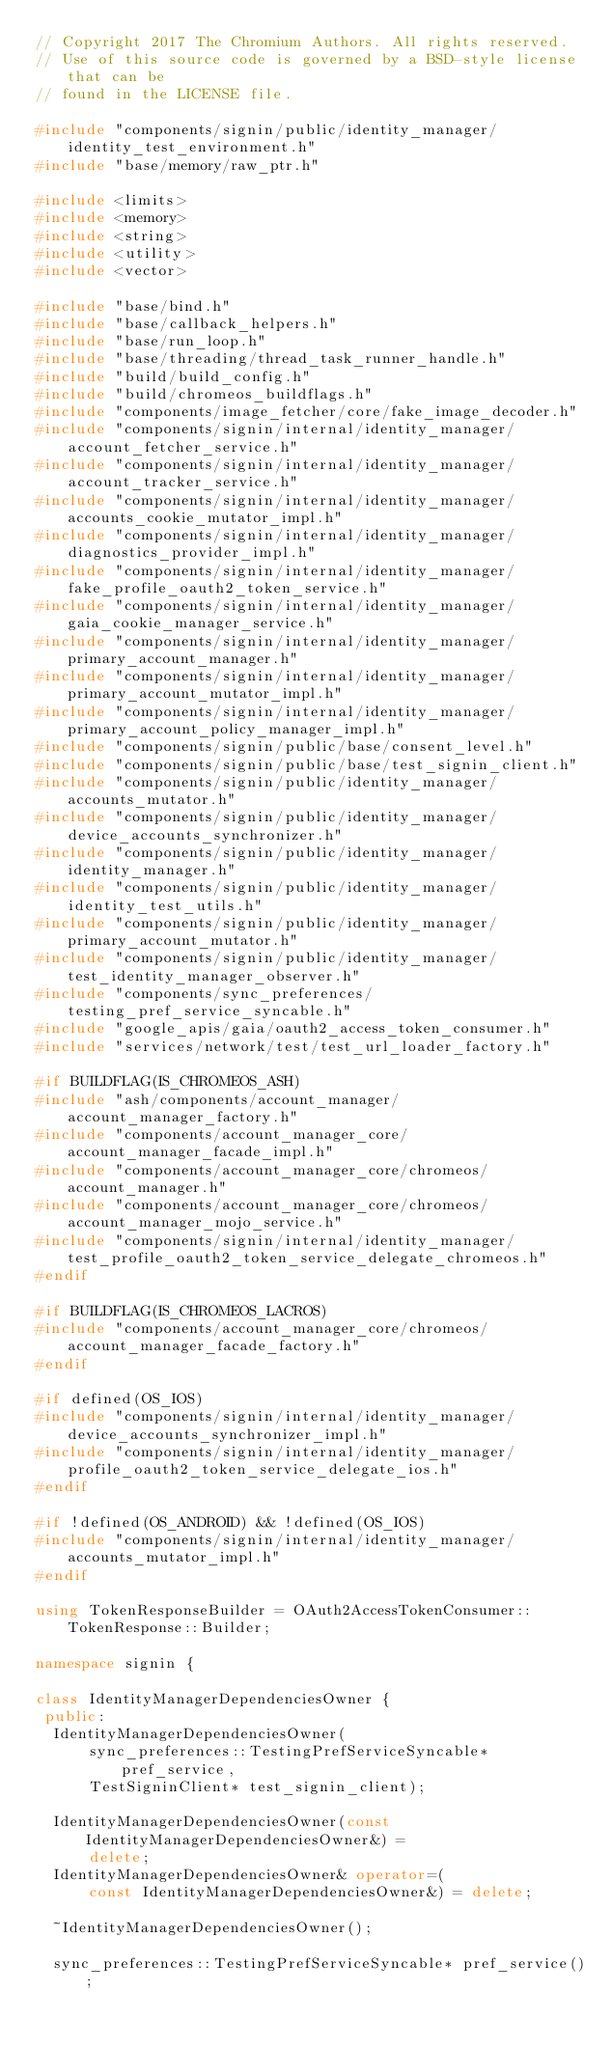Convert code to text. <code><loc_0><loc_0><loc_500><loc_500><_C++_>// Copyright 2017 The Chromium Authors. All rights reserved.
// Use of this source code is governed by a BSD-style license that can be
// found in the LICENSE file.

#include "components/signin/public/identity_manager/identity_test_environment.h"
#include "base/memory/raw_ptr.h"

#include <limits>
#include <memory>
#include <string>
#include <utility>
#include <vector>

#include "base/bind.h"
#include "base/callback_helpers.h"
#include "base/run_loop.h"
#include "base/threading/thread_task_runner_handle.h"
#include "build/build_config.h"
#include "build/chromeos_buildflags.h"
#include "components/image_fetcher/core/fake_image_decoder.h"
#include "components/signin/internal/identity_manager/account_fetcher_service.h"
#include "components/signin/internal/identity_manager/account_tracker_service.h"
#include "components/signin/internal/identity_manager/accounts_cookie_mutator_impl.h"
#include "components/signin/internal/identity_manager/diagnostics_provider_impl.h"
#include "components/signin/internal/identity_manager/fake_profile_oauth2_token_service.h"
#include "components/signin/internal/identity_manager/gaia_cookie_manager_service.h"
#include "components/signin/internal/identity_manager/primary_account_manager.h"
#include "components/signin/internal/identity_manager/primary_account_mutator_impl.h"
#include "components/signin/internal/identity_manager/primary_account_policy_manager_impl.h"
#include "components/signin/public/base/consent_level.h"
#include "components/signin/public/base/test_signin_client.h"
#include "components/signin/public/identity_manager/accounts_mutator.h"
#include "components/signin/public/identity_manager/device_accounts_synchronizer.h"
#include "components/signin/public/identity_manager/identity_manager.h"
#include "components/signin/public/identity_manager/identity_test_utils.h"
#include "components/signin/public/identity_manager/primary_account_mutator.h"
#include "components/signin/public/identity_manager/test_identity_manager_observer.h"
#include "components/sync_preferences/testing_pref_service_syncable.h"
#include "google_apis/gaia/oauth2_access_token_consumer.h"
#include "services/network/test/test_url_loader_factory.h"

#if BUILDFLAG(IS_CHROMEOS_ASH)
#include "ash/components/account_manager/account_manager_factory.h"
#include "components/account_manager_core/account_manager_facade_impl.h"
#include "components/account_manager_core/chromeos/account_manager.h"
#include "components/account_manager_core/chromeos/account_manager_mojo_service.h"
#include "components/signin/internal/identity_manager/test_profile_oauth2_token_service_delegate_chromeos.h"
#endif

#if BUILDFLAG(IS_CHROMEOS_LACROS)
#include "components/account_manager_core/chromeos/account_manager_facade_factory.h"
#endif

#if defined(OS_IOS)
#include "components/signin/internal/identity_manager/device_accounts_synchronizer_impl.h"
#include "components/signin/internal/identity_manager/profile_oauth2_token_service_delegate_ios.h"
#endif

#if !defined(OS_ANDROID) && !defined(OS_IOS)
#include "components/signin/internal/identity_manager/accounts_mutator_impl.h"
#endif

using TokenResponseBuilder = OAuth2AccessTokenConsumer::TokenResponse::Builder;

namespace signin {

class IdentityManagerDependenciesOwner {
 public:
  IdentityManagerDependenciesOwner(
      sync_preferences::TestingPrefServiceSyncable* pref_service,
      TestSigninClient* test_signin_client);

  IdentityManagerDependenciesOwner(const IdentityManagerDependenciesOwner&) =
      delete;
  IdentityManagerDependenciesOwner& operator=(
      const IdentityManagerDependenciesOwner&) = delete;

  ~IdentityManagerDependenciesOwner();

  sync_preferences::TestingPrefServiceSyncable* pref_service();</code> 